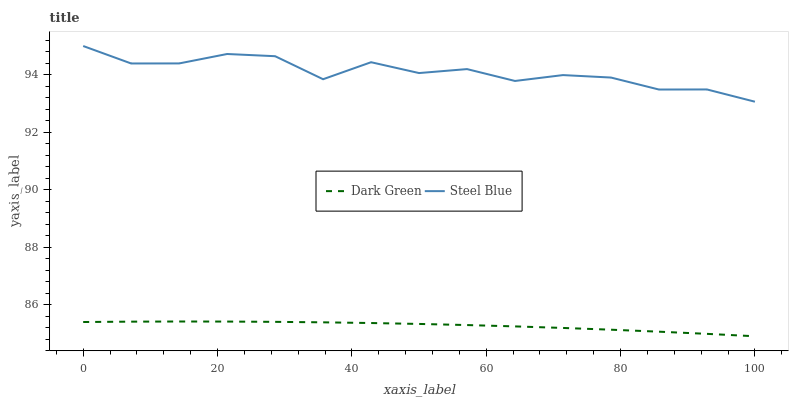Does Dark Green have the minimum area under the curve?
Answer yes or no. Yes. Does Steel Blue have the maximum area under the curve?
Answer yes or no. Yes. Does Dark Green have the maximum area under the curve?
Answer yes or no. No. Is Dark Green the smoothest?
Answer yes or no. Yes. Is Steel Blue the roughest?
Answer yes or no. Yes. Is Dark Green the roughest?
Answer yes or no. No. Does Dark Green have the lowest value?
Answer yes or no. Yes. Does Steel Blue have the highest value?
Answer yes or no. Yes. Does Dark Green have the highest value?
Answer yes or no. No. Is Dark Green less than Steel Blue?
Answer yes or no. Yes. Is Steel Blue greater than Dark Green?
Answer yes or no. Yes. Does Dark Green intersect Steel Blue?
Answer yes or no. No. 